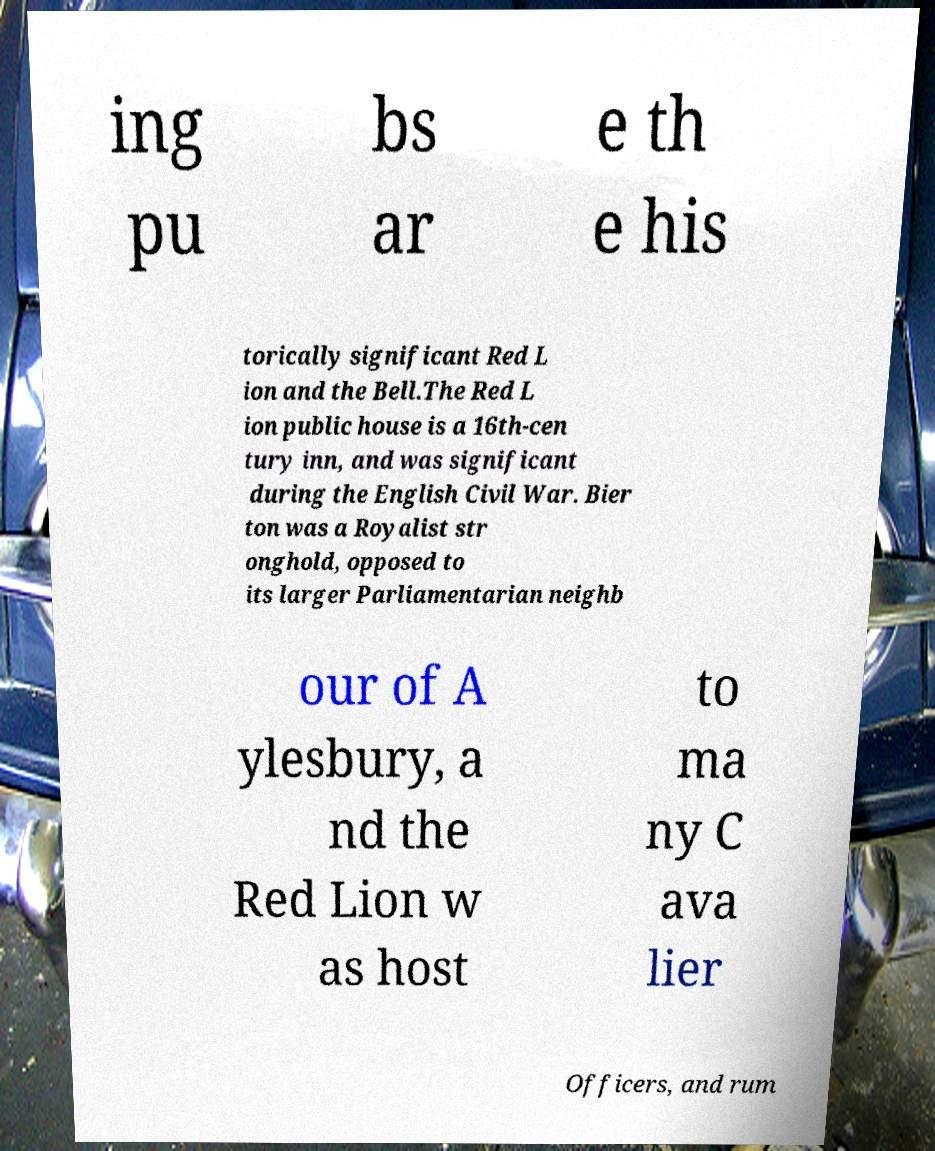There's text embedded in this image that I need extracted. Can you transcribe it verbatim? ing pu bs ar e th e his torically significant Red L ion and the Bell.The Red L ion public house is a 16th-cen tury inn, and was significant during the English Civil War. Bier ton was a Royalist str onghold, opposed to its larger Parliamentarian neighb our of A ylesbury, a nd the Red Lion w as host to ma ny C ava lier Officers, and rum 